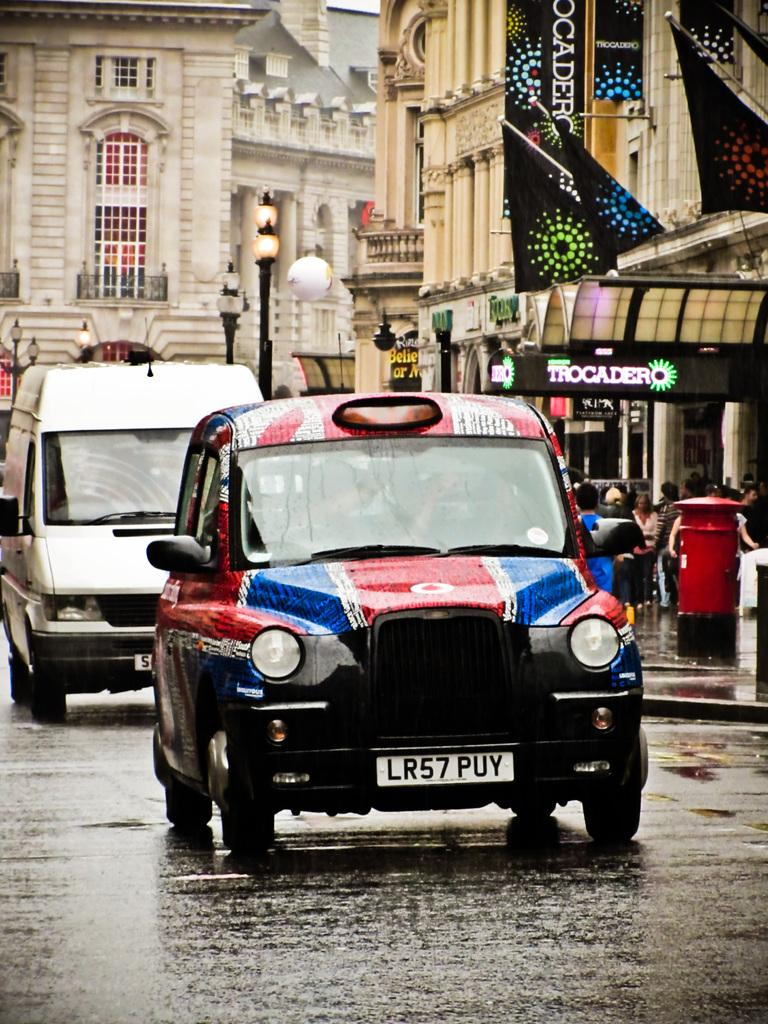What can be seen on the road in the image? There are vehicles on the road in the image. What is visible in the background of the image? There are buildings and poles in the background of the image. Are there any people visible in the image? Yes, there are persons in the background of the image. What type of wheel is being distributed to the buildings in the image? There is no mention of a wheel or distribution in the image; it features vehicles on the road and buildings in the background. 